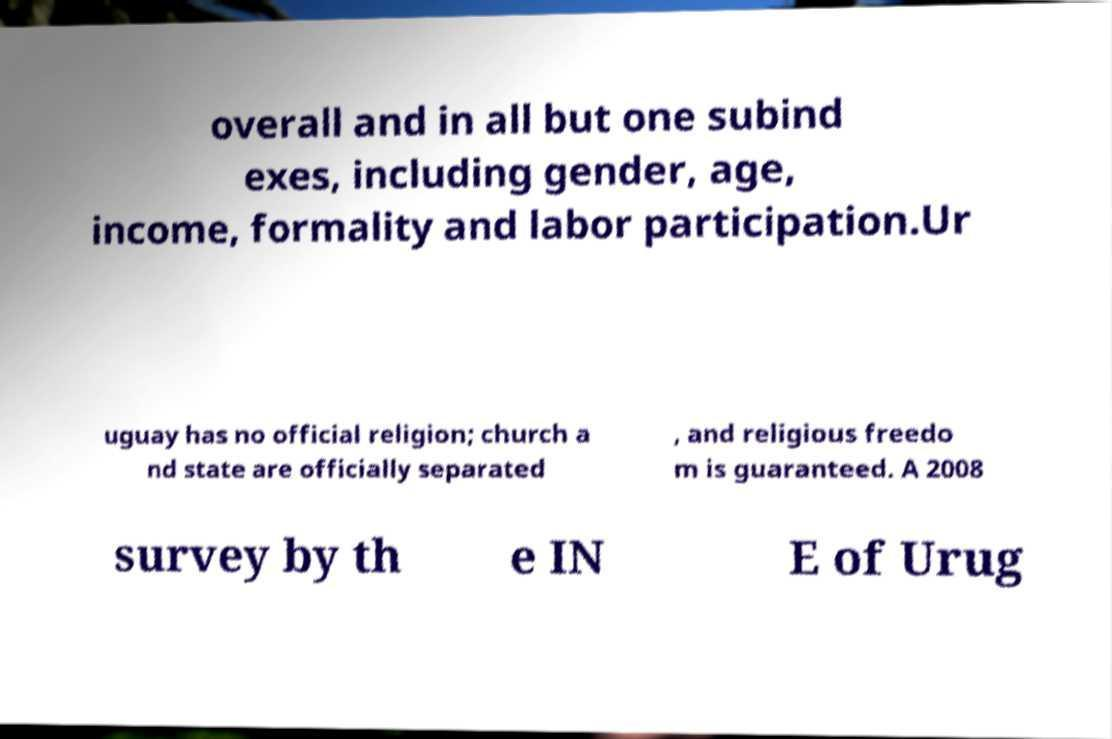There's text embedded in this image that I need extracted. Can you transcribe it verbatim? overall and in all but one subind exes, including gender, age, income, formality and labor participation.Ur uguay has no official religion; church a nd state are officially separated , and religious freedo m is guaranteed. A 2008 survey by th e IN E of Urug 